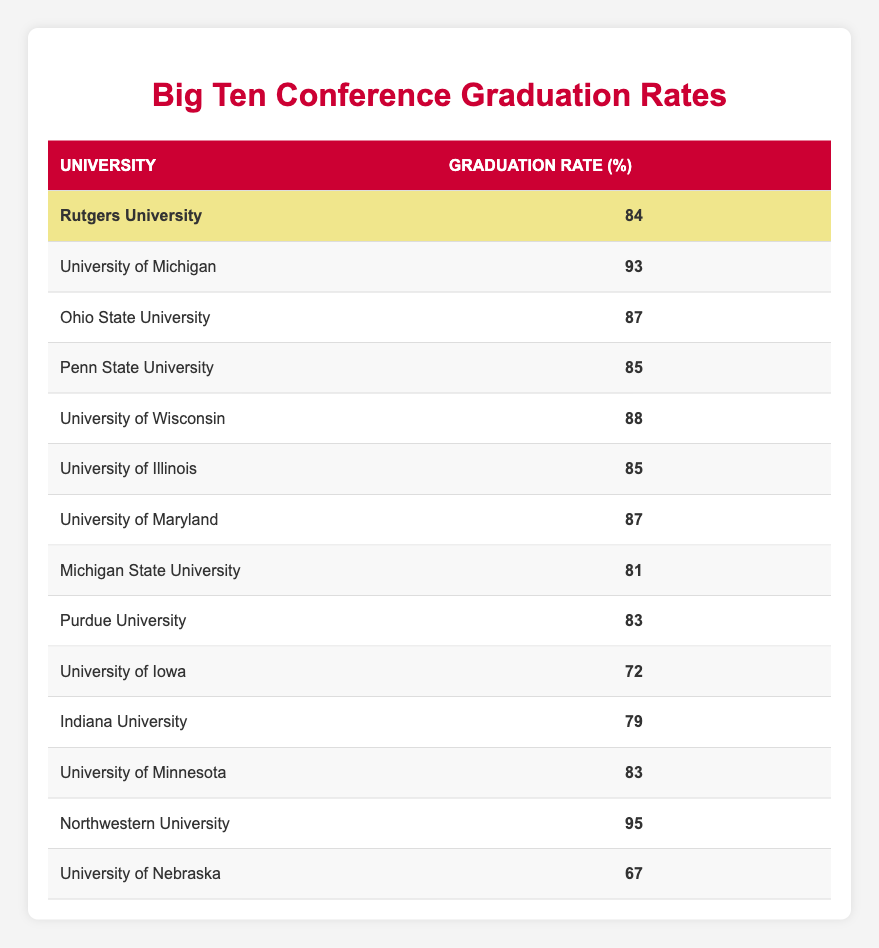What is the graduation rate of Rutgers University? The table lists the graduation rate for each university, and the corresponding value for Rutgers University is given directly as 84%.
Answer: 84 Which university has the highest graduation rate? By comparing the graduation rates for all universities in the table, Northwestern University has the highest rate at 95%.
Answer: 95 What is the average graduation rate for the universities listed in the table? To find the average graduation rate, sum up all the rates (84 + 93 + 87 + 85 + 88 + 85 + 87 + 81 + 83 + 72 + 79 + 83 + 95 + 67) = 1155. There are 14 universities, so the average is 1155 / 14 ≈ 82.5.
Answer: Approximately 82.5 Is the graduation rate of University of Iowa higher than that of Indiana University? The graduation rate for University of Iowa is 72% and for Indiana University it is 79%. Since 72% is less than 79%, the statement is false.
Answer: No What is the difference between the graduation rates of the university with the highest rate and the lowest rate? The highest graduation rate is Northwestern University at 95%, and the lowest is University of Nebraska at 67%. The difference is calculated as 95 - 67 = 28.
Answer: 28 How many universities have a graduation rate of 85% or higher? By counting the universities with rates listed as 85% or higher, we find the following: University of Michigan (93), Ohio State University (87), Penn State University (85), University of Wisconsin (88), University of Maryland (87), and Northwestern University (95). That's a total of 6 universities.
Answer: 6 What is the graduation rate of the lowest-ranked university? The University of Nebraska has the lowest graduation rate in the table, listed at 67%.
Answer: 67 If we exclude Rutgers University, what is the highest graduation rate among the remaining universities? Excluding Rutgers University, we look for the highest value in the remaining rates. Northwestern University at 95% remains the highest, followed by University of Michigan at 93%.
Answer: 95 Which two universities have identical graduation rates? Upon reviewing the table, both Penn State University and University of Illinois have identical graduation rates, each at 85%.
Answer: Penn State University and University of Illinois 